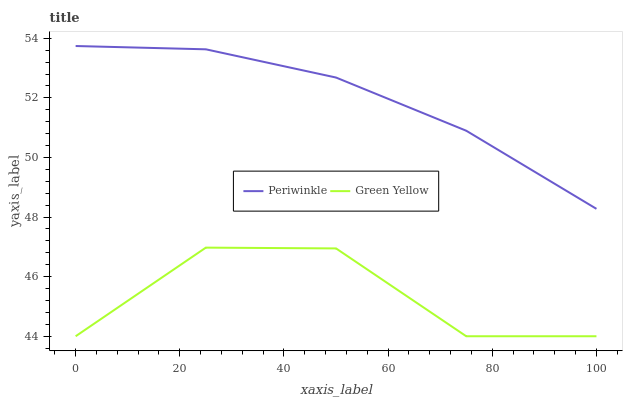Does Periwinkle have the minimum area under the curve?
Answer yes or no. No. Is Periwinkle the roughest?
Answer yes or no. No. Does Periwinkle have the lowest value?
Answer yes or no. No. Is Green Yellow less than Periwinkle?
Answer yes or no. Yes. Is Periwinkle greater than Green Yellow?
Answer yes or no. Yes. Does Green Yellow intersect Periwinkle?
Answer yes or no. No. 